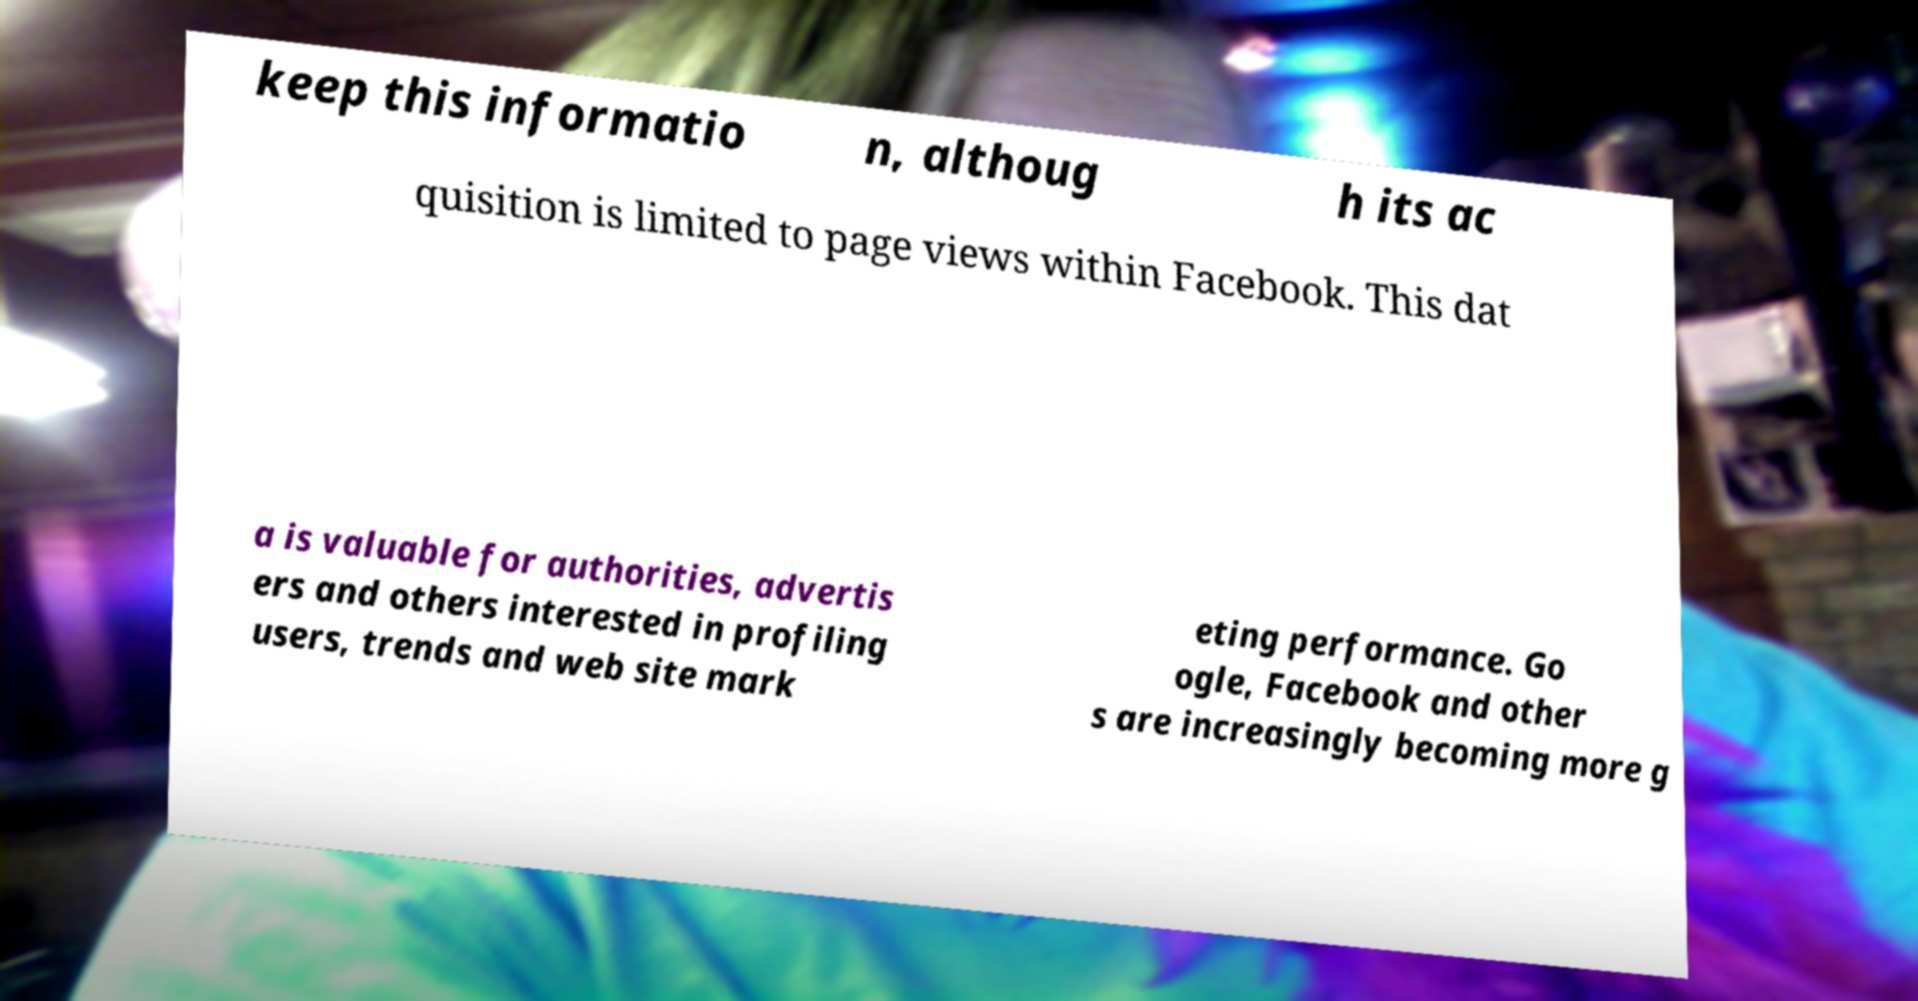I need the written content from this picture converted into text. Can you do that? keep this informatio n, althoug h its ac quisition is limited to page views within Facebook. This dat a is valuable for authorities, advertis ers and others interested in profiling users, trends and web site mark eting performance. Go ogle, Facebook and other s are increasingly becoming more g 